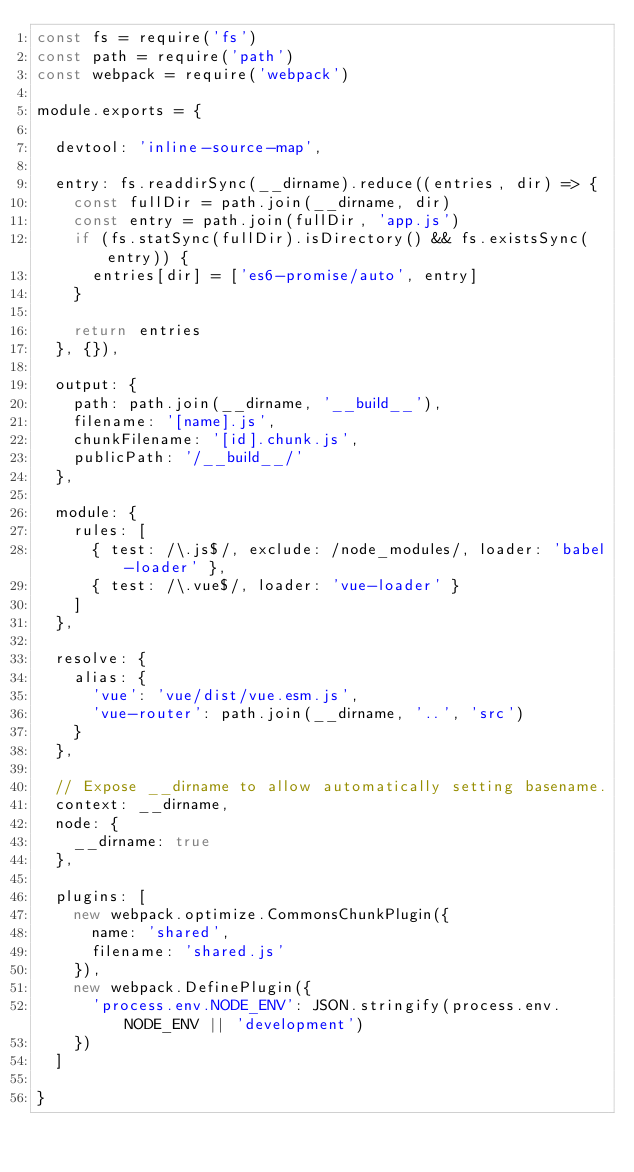<code> <loc_0><loc_0><loc_500><loc_500><_JavaScript_>const fs = require('fs')
const path = require('path')
const webpack = require('webpack')

module.exports = {

  devtool: 'inline-source-map',

  entry: fs.readdirSync(__dirname).reduce((entries, dir) => {
    const fullDir = path.join(__dirname, dir)
    const entry = path.join(fullDir, 'app.js')
    if (fs.statSync(fullDir).isDirectory() && fs.existsSync(entry)) {
      entries[dir] = ['es6-promise/auto', entry]
    }

    return entries
  }, {}),

  output: {
    path: path.join(__dirname, '__build__'),
    filename: '[name].js',
    chunkFilename: '[id].chunk.js',
    publicPath: '/__build__/'
  },

  module: {
    rules: [
      { test: /\.js$/, exclude: /node_modules/, loader: 'babel-loader' },
      { test: /\.vue$/, loader: 'vue-loader' }
    ]
  },

  resolve: {
    alias: {
      'vue': 'vue/dist/vue.esm.js',
      'vue-router': path.join(__dirname, '..', 'src')
    }
  },

  // Expose __dirname to allow automatically setting basename.
  context: __dirname,
  node: {
    __dirname: true
  },

  plugins: [
    new webpack.optimize.CommonsChunkPlugin({
      name: 'shared',
      filename: 'shared.js'
    }),
    new webpack.DefinePlugin({
      'process.env.NODE_ENV': JSON.stringify(process.env.NODE_ENV || 'development')
    })
  ]

}
</code> 